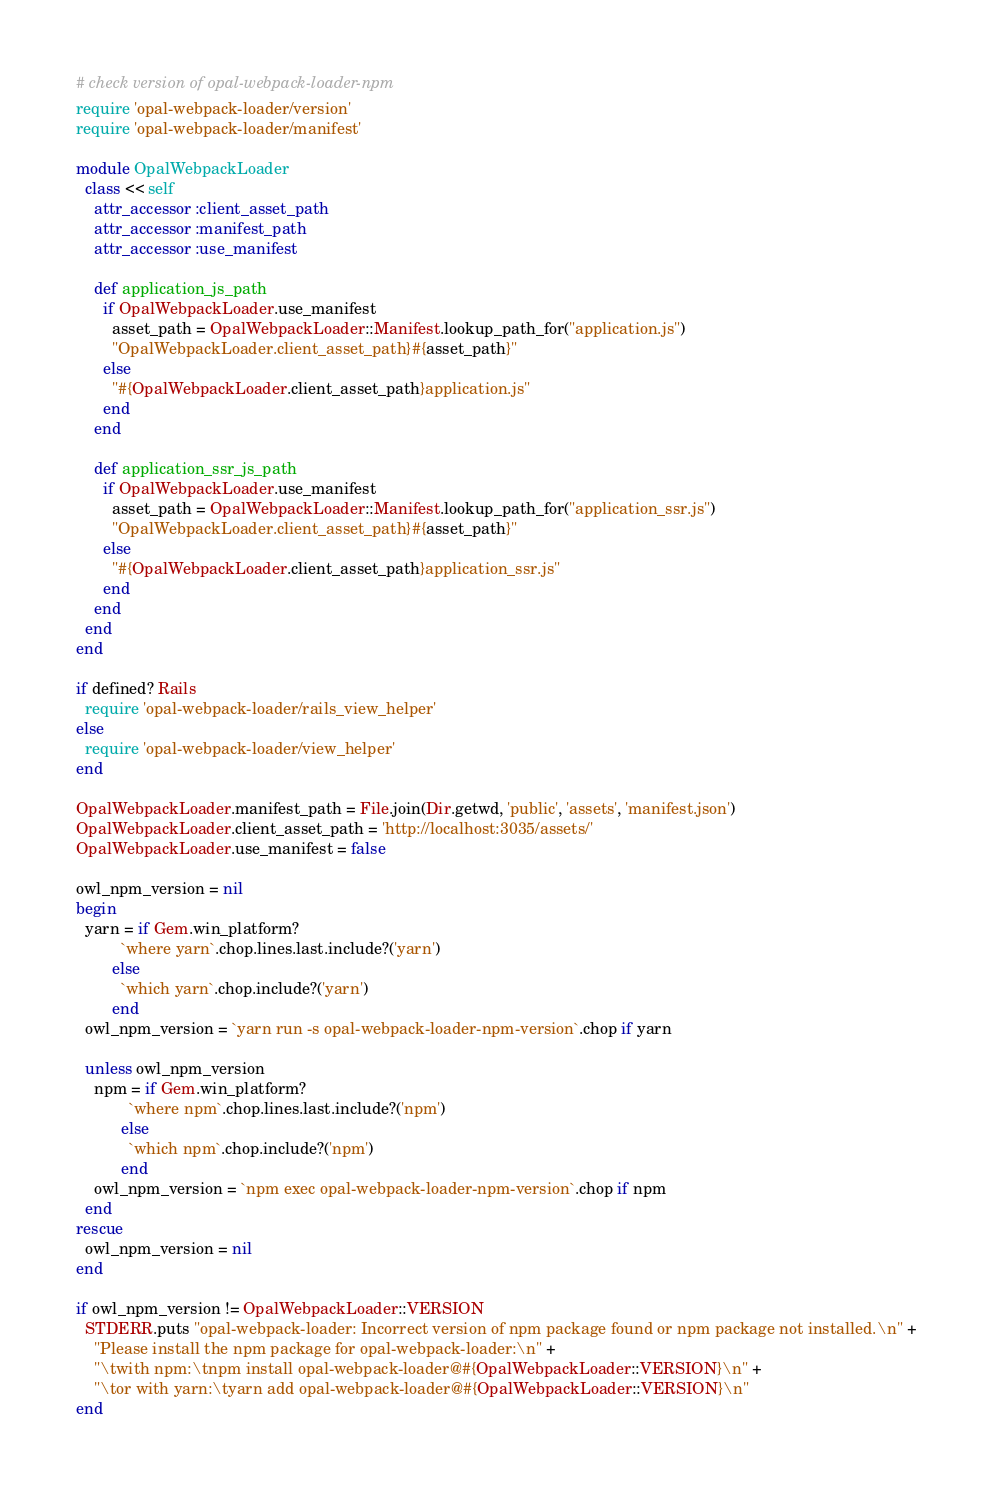Convert code to text. <code><loc_0><loc_0><loc_500><loc_500><_Ruby_># check version of opal-webpack-loader-npm
require 'opal-webpack-loader/version'
require 'opal-webpack-loader/manifest'

module OpalWebpackLoader
  class << self
    attr_accessor :client_asset_path
    attr_accessor :manifest_path
    attr_accessor :use_manifest

    def application_js_path
      if OpalWebpackLoader.use_manifest
        asset_path = OpalWebpackLoader::Manifest.lookup_path_for("application.js")
        "OpalWebpackLoader.client_asset_path}#{asset_path}"
      else
        "#{OpalWebpackLoader.client_asset_path}application.js"
      end
    end

    def application_ssr_js_path
      if OpalWebpackLoader.use_manifest
        asset_path = OpalWebpackLoader::Manifest.lookup_path_for("application_ssr.js")
        "OpalWebpackLoader.client_asset_path}#{asset_path}"
      else
        "#{OpalWebpackLoader.client_asset_path}application_ssr.js"
      end
    end
  end
end

if defined? Rails
  require 'opal-webpack-loader/rails_view_helper'
else
  require 'opal-webpack-loader/view_helper'
end

OpalWebpackLoader.manifest_path = File.join(Dir.getwd, 'public', 'assets', 'manifest.json')
OpalWebpackLoader.client_asset_path = 'http://localhost:3035/assets/'
OpalWebpackLoader.use_manifest = false

owl_npm_version = nil
begin
  yarn = if Gem.win_platform?
          `where yarn`.chop.lines.last.include?('yarn')
        else
          `which yarn`.chop.include?('yarn')
        end
  owl_npm_version = `yarn run -s opal-webpack-loader-npm-version`.chop if yarn

  unless owl_npm_version
    npm = if Gem.win_platform?
            `where npm`.chop.lines.last.include?('npm')
          else
            `which npm`.chop.include?('npm')
          end
    owl_npm_version = `npm exec opal-webpack-loader-npm-version`.chop if npm
  end
rescue
  owl_npm_version = nil
end

if owl_npm_version != OpalWebpackLoader::VERSION
  STDERR.puts "opal-webpack-loader: Incorrect version of npm package found or npm package not installed.\n" +
    "Please install the npm package for opal-webpack-loader:\n" +
    "\twith npm:\tnpm install opal-webpack-loader@#{OpalWebpackLoader::VERSION}\n" +
    "\tor with yarn:\tyarn add opal-webpack-loader@#{OpalWebpackLoader::VERSION}\n"
end

</code> 